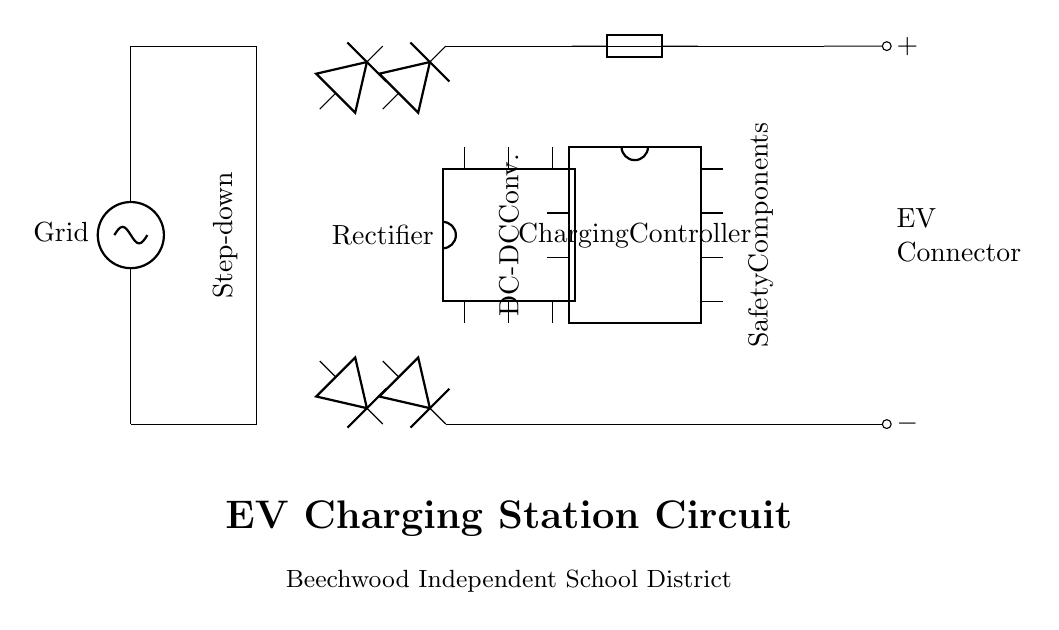What is the main power source for this charging station? The main power source is labeled as "Grid," indicating that it is powered by the electrical grid.
Answer: Grid What type of transformer is used in this circuit? The diagram does not specify the exact type of transformer but it shows a transformer symbol which typically indicates it's a step-down transformer used to reduce voltage levels.
Answer: Step-down How many diodes are present in the rectifier section? By counting the diode symbols in the diagram, there are a total of four diodes shown connected in a bridge configuration.
Answer: Four What is the role of the Charging Controller? The Charging Controller is responsible for managing and controlling the charging process for the electric vehicle to ensure safety and efficiency.
Answer: Charging process management What safety components are indicated in the circuit? The circuit highlights a fuse and an electrical mechanism as safety components which prevent overload and protect the circuit.
Answer: Fuse and electrical mechanism What type of converter is used in this circuit? The circuit includes a DC-DC converter, which translates the DC voltage to a desired level suitable for electric vehicle charging through the controllers.
Answer: DC-DC converter What does the EV Connector represent in this circuit? The EV Connector is where the electric vehicle would plug in to receive power, indicated by positive and negative connections.
Answer: Power connection point 